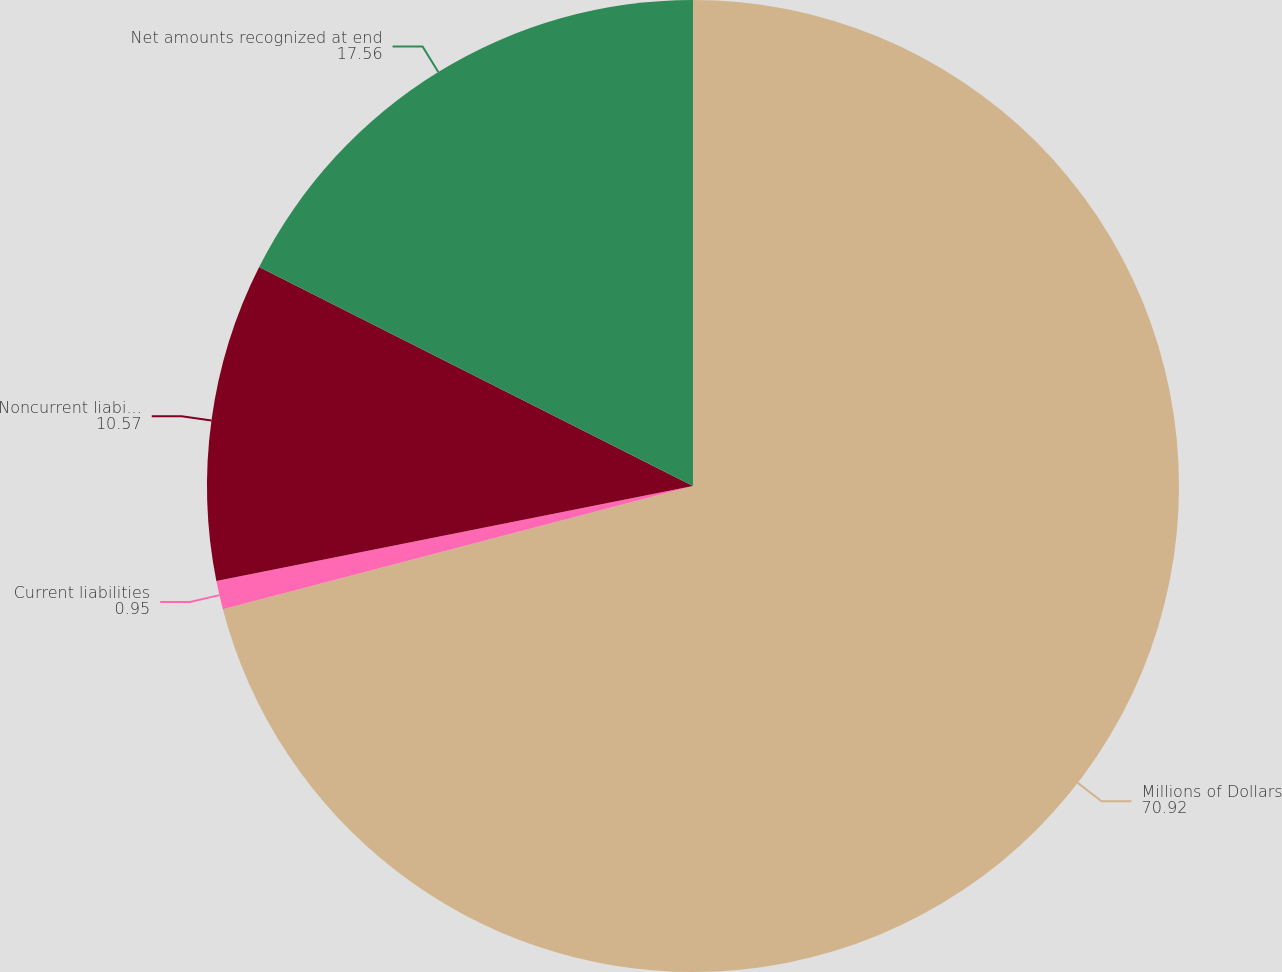Convert chart to OTSL. <chart><loc_0><loc_0><loc_500><loc_500><pie_chart><fcel>Millions of Dollars<fcel>Current liabilities<fcel>Noncurrent liabilities<fcel>Net amounts recognized at end<nl><fcel>70.92%<fcel>0.95%<fcel>10.57%<fcel>17.56%<nl></chart> 